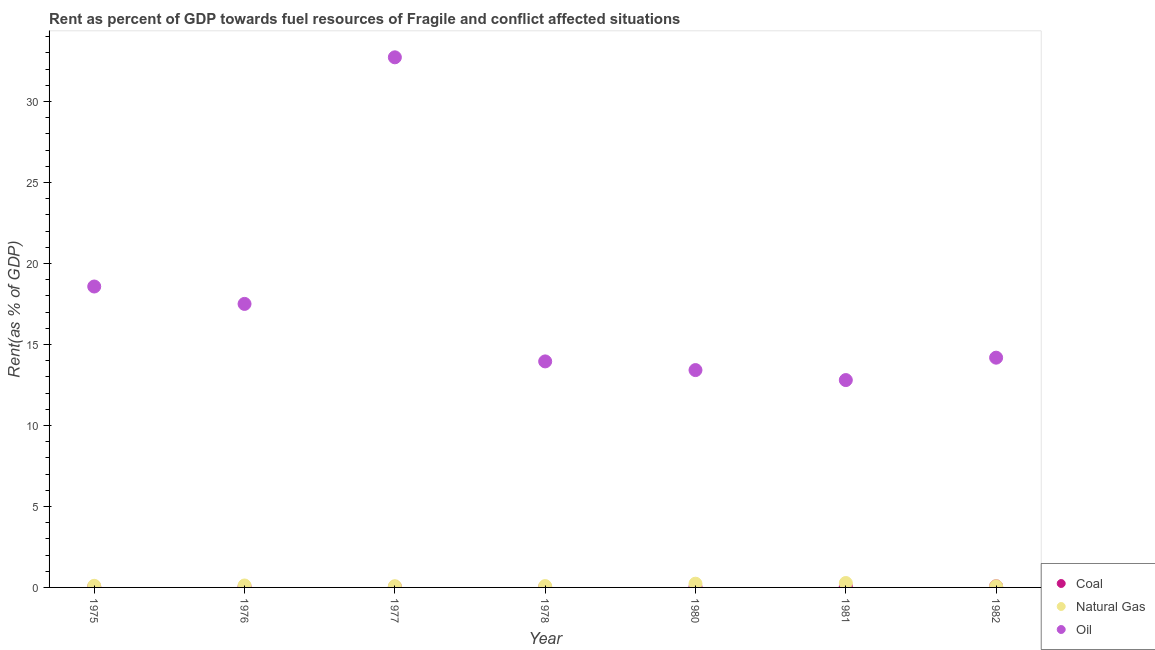Is the number of dotlines equal to the number of legend labels?
Make the answer very short. Yes. What is the rent towards natural gas in 1977?
Offer a terse response. 0.08. Across all years, what is the maximum rent towards natural gas?
Offer a terse response. 0.27. Across all years, what is the minimum rent towards coal?
Provide a short and direct response. 0.02. In which year was the rent towards oil minimum?
Offer a very short reply. 1981. What is the total rent towards natural gas in the graph?
Give a very brief answer. 0.95. What is the difference between the rent towards oil in 1978 and that in 1982?
Ensure brevity in your answer.  -0.23. What is the difference between the rent towards natural gas in 1978 and the rent towards oil in 1977?
Keep it short and to the point. -32.65. What is the average rent towards oil per year?
Provide a short and direct response. 17.6. In the year 1975, what is the difference between the rent towards natural gas and rent towards coal?
Your answer should be compact. 0.06. In how many years, is the rent towards coal greater than 12 %?
Your response must be concise. 0. What is the ratio of the rent towards oil in 1975 to that in 1977?
Offer a terse response. 0.57. What is the difference between the highest and the second highest rent towards oil?
Provide a short and direct response. 14.15. What is the difference between the highest and the lowest rent towards natural gas?
Make the answer very short. 0.2. Is the sum of the rent towards natural gas in 1977 and 1981 greater than the maximum rent towards oil across all years?
Offer a terse response. No. Is it the case that in every year, the sum of the rent towards coal and rent towards natural gas is greater than the rent towards oil?
Your response must be concise. No. Is the rent towards oil strictly greater than the rent towards natural gas over the years?
Ensure brevity in your answer.  Yes. How many years are there in the graph?
Make the answer very short. 7. What is the difference between two consecutive major ticks on the Y-axis?
Make the answer very short. 5. Are the values on the major ticks of Y-axis written in scientific E-notation?
Offer a terse response. No. Does the graph contain grids?
Provide a succinct answer. No. Where does the legend appear in the graph?
Make the answer very short. Bottom right. What is the title of the graph?
Provide a succinct answer. Rent as percent of GDP towards fuel resources of Fragile and conflict affected situations. What is the label or title of the Y-axis?
Provide a short and direct response. Rent(as % of GDP). What is the Rent(as % of GDP) of Coal in 1975?
Your response must be concise. 0.04. What is the Rent(as % of GDP) of Natural Gas in 1975?
Your answer should be compact. 0.1. What is the Rent(as % of GDP) of Oil in 1975?
Offer a very short reply. 18.58. What is the Rent(as % of GDP) of Coal in 1976?
Offer a very short reply. 0.05. What is the Rent(as % of GDP) in Natural Gas in 1976?
Make the answer very short. 0.12. What is the Rent(as % of GDP) of Oil in 1976?
Keep it short and to the point. 17.5. What is the Rent(as % of GDP) of Coal in 1977?
Make the answer very short. 0.04. What is the Rent(as % of GDP) in Natural Gas in 1977?
Make the answer very short. 0.08. What is the Rent(as % of GDP) in Oil in 1977?
Offer a terse response. 32.73. What is the Rent(as % of GDP) in Coal in 1978?
Give a very brief answer. 0.02. What is the Rent(as % of GDP) of Natural Gas in 1978?
Ensure brevity in your answer.  0.08. What is the Rent(as % of GDP) in Oil in 1978?
Make the answer very short. 13.96. What is the Rent(as % of GDP) of Coal in 1980?
Offer a terse response. 0.03. What is the Rent(as % of GDP) in Natural Gas in 1980?
Offer a very short reply. 0.23. What is the Rent(as % of GDP) of Oil in 1980?
Give a very brief answer. 13.42. What is the Rent(as % of GDP) in Coal in 1981?
Ensure brevity in your answer.  0.07. What is the Rent(as % of GDP) of Natural Gas in 1981?
Give a very brief answer. 0.27. What is the Rent(as % of GDP) in Oil in 1981?
Provide a short and direct response. 12.8. What is the Rent(as % of GDP) in Coal in 1982?
Provide a short and direct response. 0.07. What is the Rent(as % of GDP) in Natural Gas in 1982?
Your answer should be compact. 0.07. What is the Rent(as % of GDP) in Oil in 1982?
Give a very brief answer. 14.19. Across all years, what is the maximum Rent(as % of GDP) in Coal?
Your answer should be compact. 0.07. Across all years, what is the maximum Rent(as % of GDP) in Natural Gas?
Provide a short and direct response. 0.27. Across all years, what is the maximum Rent(as % of GDP) of Oil?
Provide a short and direct response. 32.73. Across all years, what is the minimum Rent(as % of GDP) of Coal?
Make the answer very short. 0.02. Across all years, what is the minimum Rent(as % of GDP) in Natural Gas?
Give a very brief answer. 0.07. Across all years, what is the minimum Rent(as % of GDP) of Oil?
Provide a short and direct response. 12.8. What is the total Rent(as % of GDP) in Coal in the graph?
Offer a very short reply. 0.31. What is the total Rent(as % of GDP) of Natural Gas in the graph?
Provide a succinct answer. 0.95. What is the total Rent(as % of GDP) in Oil in the graph?
Keep it short and to the point. 123.17. What is the difference between the Rent(as % of GDP) of Coal in 1975 and that in 1976?
Keep it short and to the point. -0. What is the difference between the Rent(as % of GDP) of Natural Gas in 1975 and that in 1976?
Provide a short and direct response. -0.02. What is the difference between the Rent(as % of GDP) in Oil in 1975 and that in 1976?
Your answer should be compact. 1.07. What is the difference between the Rent(as % of GDP) in Coal in 1975 and that in 1977?
Keep it short and to the point. 0.01. What is the difference between the Rent(as % of GDP) in Natural Gas in 1975 and that in 1977?
Give a very brief answer. 0.02. What is the difference between the Rent(as % of GDP) in Oil in 1975 and that in 1977?
Make the answer very short. -14.15. What is the difference between the Rent(as % of GDP) of Coal in 1975 and that in 1978?
Offer a very short reply. 0.02. What is the difference between the Rent(as % of GDP) in Natural Gas in 1975 and that in 1978?
Provide a short and direct response. 0.02. What is the difference between the Rent(as % of GDP) in Oil in 1975 and that in 1978?
Your answer should be compact. 4.62. What is the difference between the Rent(as % of GDP) in Coal in 1975 and that in 1980?
Ensure brevity in your answer.  0.01. What is the difference between the Rent(as % of GDP) of Natural Gas in 1975 and that in 1980?
Your response must be concise. -0.13. What is the difference between the Rent(as % of GDP) in Oil in 1975 and that in 1980?
Your answer should be compact. 5.16. What is the difference between the Rent(as % of GDP) of Coal in 1975 and that in 1981?
Ensure brevity in your answer.  -0.02. What is the difference between the Rent(as % of GDP) of Natural Gas in 1975 and that in 1981?
Offer a terse response. -0.17. What is the difference between the Rent(as % of GDP) in Oil in 1975 and that in 1981?
Offer a terse response. 5.78. What is the difference between the Rent(as % of GDP) of Coal in 1975 and that in 1982?
Keep it short and to the point. -0.02. What is the difference between the Rent(as % of GDP) in Natural Gas in 1975 and that in 1982?
Keep it short and to the point. 0.03. What is the difference between the Rent(as % of GDP) of Oil in 1975 and that in 1982?
Your answer should be very brief. 4.39. What is the difference between the Rent(as % of GDP) in Coal in 1976 and that in 1977?
Offer a terse response. 0.01. What is the difference between the Rent(as % of GDP) of Natural Gas in 1976 and that in 1977?
Your response must be concise. 0.04. What is the difference between the Rent(as % of GDP) in Oil in 1976 and that in 1977?
Offer a terse response. -15.22. What is the difference between the Rent(as % of GDP) of Coal in 1976 and that in 1978?
Offer a very short reply. 0.02. What is the difference between the Rent(as % of GDP) of Natural Gas in 1976 and that in 1978?
Keep it short and to the point. 0.04. What is the difference between the Rent(as % of GDP) of Oil in 1976 and that in 1978?
Ensure brevity in your answer.  3.55. What is the difference between the Rent(as % of GDP) of Coal in 1976 and that in 1980?
Give a very brief answer. 0.01. What is the difference between the Rent(as % of GDP) of Natural Gas in 1976 and that in 1980?
Your answer should be compact. -0.11. What is the difference between the Rent(as % of GDP) in Oil in 1976 and that in 1980?
Offer a very short reply. 4.09. What is the difference between the Rent(as % of GDP) of Coal in 1976 and that in 1981?
Keep it short and to the point. -0.02. What is the difference between the Rent(as % of GDP) in Natural Gas in 1976 and that in 1981?
Offer a very short reply. -0.15. What is the difference between the Rent(as % of GDP) of Oil in 1976 and that in 1981?
Your answer should be compact. 4.7. What is the difference between the Rent(as % of GDP) in Coal in 1976 and that in 1982?
Your answer should be compact. -0.02. What is the difference between the Rent(as % of GDP) of Natural Gas in 1976 and that in 1982?
Your answer should be compact. 0.05. What is the difference between the Rent(as % of GDP) of Oil in 1976 and that in 1982?
Your response must be concise. 3.32. What is the difference between the Rent(as % of GDP) in Coal in 1977 and that in 1978?
Provide a short and direct response. 0.01. What is the difference between the Rent(as % of GDP) of Natural Gas in 1977 and that in 1978?
Your answer should be very brief. -0.01. What is the difference between the Rent(as % of GDP) in Oil in 1977 and that in 1978?
Offer a very short reply. 18.77. What is the difference between the Rent(as % of GDP) in Coal in 1977 and that in 1980?
Your response must be concise. 0. What is the difference between the Rent(as % of GDP) in Natural Gas in 1977 and that in 1980?
Make the answer very short. -0.15. What is the difference between the Rent(as % of GDP) of Oil in 1977 and that in 1980?
Provide a short and direct response. 19.31. What is the difference between the Rent(as % of GDP) of Coal in 1977 and that in 1981?
Ensure brevity in your answer.  -0.03. What is the difference between the Rent(as % of GDP) in Natural Gas in 1977 and that in 1981?
Your response must be concise. -0.19. What is the difference between the Rent(as % of GDP) in Oil in 1977 and that in 1981?
Keep it short and to the point. 19.93. What is the difference between the Rent(as % of GDP) in Coal in 1977 and that in 1982?
Your response must be concise. -0.03. What is the difference between the Rent(as % of GDP) in Natural Gas in 1977 and that in 1982?
Offer a terse response. 0. What is the difference between the Rent(as % of GDP) of Oil in 1977 and that in 1982?
Your answer should be compact. 18.54. What is the difference between the Rent(as % of GDP) of Coal in 1978 and that in 1980?
Your answer should be compact. -0.01. What is the difference between the Rent(as % of GDP) in Natural Gas in 1978 and that in 1980?
Offer a terse response. -0.15. What is the difference between the Rent(as % of GDP) of Oil in 1978 and that in 1980?
Your answer should be very brief. 0.54. What is the difference between the Rent(as % of GDP) in Coal in 1978 and that in 1981?
Your answer should be compact. -0.04. What is the difference between the Rent(as % of GDP) of Natural Gas in 1978 and that in 1981?
Keep it short and to the point. -0.19. What is the difference between the Rent(as % of GDP) of Oil in 1978 and that in 1981?
Offer a very short reply. 1.15. What is the difference between the Rent(as % of GDP) of Coal in 1978 and that in 1982?
Offer a very short reply. -0.05. What is the difference between the Rent(as % of GDP) of Natural Gas in 1978 and that in 1982?
Ensure brevity in your answer.  0.01. What is the difference between the Rent(as % of GDP) in Oil in 1978 and that in 1982?
Give a very brief answer. -0.23. What is the difference between the Rent(as % of GDP) in Coal in 1980 and that in 1981?
Give a very brief answer. -0.03. What is the difference between the Rent(as % of GDP) in Natural Gas in 1980 and that in 1981?
Offer a terse response. -0.04. What is the difference between the Rent(as % of GDP) of Oil in 1980 and that in 1981?
Provide a short and direct response. 0.62. What is the difference between the Rent(as % of GDP) of Coal in 1980 and that in 1982?
Your answer should be very brief. -0.04. What is the difference between the Rent(as % of GDP) in Natural Gas in 1980 and that in 1982?
Keep it short and to the point. 0.16. What is the difference between the Rent(as % of GDP) of Oil in 1980 and that in 1982?
Your answer should be compact. -0.77. What is the difference between the Rent(as % of GDP) of Coal in 1981 and that in 1982?
Offer a very short reply. -0. What is the difference between the Rent(as % of GDP) in Natural Gas in 1981 and that in 1982?
Your response must be concise. 0.2. What is the difference between the Rent(as % of GDP) of Oil in 1981 and that in 1982?
Make the answer very short. -1.38. What is the difference between the Rent(as % of GDP) in Coal in 1975 and the Rent(as % of GDP) in Natural Gas in 1976?
Your answer should be compact. -0.08. What is the difference between the Rent(as % of GDP) in Coal in 1975 and the Rent(as % of GDP) in Oil in 1976?
Offer a terse response. -17.46. What is the difference between the Rent(as % of GDP) of Natural Gas in 1975 and the Rent(as % of GDP) of Oil in 1976?
Provide a short and direct response. -17.41. What is the difference between the Rent(as % of GDP) of Coal in 1975 and the Rent(as % of GDP) of Natural Gas in 1977?
Make the answer very short. -0.03. What is the difference between the Rent(as % of GDP) in Coal in 1975 and the Rent(as % of GDP) in Oil in 1977?
Offer a very short reply. -32.69. What is the difference between the Rent(as % of GDP) in Natural Gas in 1975 and the Rent(as % of GDP) in Oil in 1977?
Provide a succinct answer. -32.63. What is the difference between the Rent(as % of GDP) of Coal in 1975 and the Rent(as % of GDP) of Natural Gas in 1978?
Keep it short and to the point. -0.04. What is the difference between the Rent(as % of GDP) in Coal in 1975 and the Rent(as % of GDP) in Oil in 1978?
Make the answer very short. -13.91. What is the difference between the Rent(as % of GDP) in Natural Gas in 1975 and the Rent(as % of GDP) in Oil in 1978?
Offer a terse response. -13.86. What is the difference between the Rent(as % of GDP) in Coal in 1975 and the Rent(as % of GDP) in Natural Gas in 1980?
Make the answer very short. -0.19. What is the difference between the Rent(as % of GDP) of Coal in 1975 and the Rent(as % of GDP) of Oil in 1980?
Provide a succinct answer. -13.38. What is the difference between the Rent(as % of GDP) of Natural Gas in 1975 and the Rent(as % of GDP) of Oil in 1980?
Ensure brevity in your answer.  -13.32. What is the difference between the Rent(as % of GDP) of Coal in 1975 and the Rent(as % of GDP) of Natural Gas in 1981?
Ensure brevity in your answer.  -0.23. What is the difference between the Rent(as % of GDP) of Coal in 1975 and the Rent(as % of GDP) of Oil in 1981?
Your response must be concise. -12.76. What is the difference between the Rent(as % of GDP) of Natural Gas in 1975 and the Rent(as % of GDP) of Oil in 1981?
Your response must be concise. -12.7. What is the difference between the Rent(as % of GDP) in Coal in 1975 and the Rent(as % of GDP) in Natural Gas in 1982?
Offer a terse response. -0.03. What is the difference between the Rent(as % of GDP) of Coal in 1975 and the Rent(as % of GDP) of Oil in 1982?
Provide a short and direct response. -14.14. What is the difference between the Rent(as % of GDP) of Natural Gas in 1975 and the Rent(as % of GDP) of Oil in 1982?
Make the answer very short. -14.09. What is the difference between the Rent(as % of GDP) in Coal in 1976 and the Rent(as % of GDP) in Natural Gas in 1977?
Provide a succinct answer. -0.03. What is the difference between the Rent(as % of GDP) of Coal in 1976 and the Rent(as % of GDP) of Oil in 1977?
Your response must be concise. -32.68. What is the difference between the Rent(as % of GDP) in Natural Gas in 1976 and the Rent(as % of GDP) in Oil in 1977?
Provide a succinct answer. -32.61. What is the difference between the Rent(as % of GDP) of Coal in 1976 and the Rent(as % of GDP) of Natural Gas in 1978?
Offer a terse response. -0.04. What is the difference between the Rent(as % of GDP) of Coal in 1976 and the Rent(as % of GDP) of Oil in 1978?
Make the answer very short. -13.91. What is the difference between the Rent(as % of GDP) of Natural Gas in 1976 and the Rent(as % of GDP) of Oil in 1978?
Offer a very short reply. -13.84. What is the difference between the Rent(as % of GDP) of Coal in 1976 and the Rent(as % of GDP) of Natural Gas in 1980?
Offer a terse response. -0.18. What is the difference between the Rent(as % of GDP) in Coal in 1976 and the Rent(as % of GDP) in Oil in 1980?
Offer a terse response. -13.37. What is the difference between the Rent(as % of GDP) in Natural Gas in 1976 and the Rent(as % of GDP) in Oil in 1980?
Your answer should be very brief. -13.3. What is the difference between the Rent(as % of GDP) of Coal in 1976 and the Rent(as % of GDP) of Natural Gas in 1981?
Provide a succinct answer. -0.23. What is the difference between the Rent(as % of GDP) in Coal in 1976 and the Rent(as % of GDP) in Oil in 1981?
Your response must be concise. -12.76. What is the difference between the Rent(as % of GDP) of Natural Gas in 1976 and the Rent(as % of GDP) of Oil in 1981?
Keep it short and to the point. -12.68. What is the difference between the Rent(as % of GDP) in Coal in 1976 and the Rent(as % of GDP) in Natural Gas in 1982?
Your response must be concise. -0.03. What is the difference between the Rent(as % of GDP) in Coal in 1976 and the Rent(as % of GDP) in Oil in 1982?
Provide a short and direct response. -14.14. What is the difference between the Rent(as % of GDP) in Natural Gas in 1976 and the Rent(as % of GDP) in Oil in 1982?
Your answer should be compact. -14.07. What is the difference between the Rent(as % of GDP) in Coal in 1977 and the Rent(as % of GDP) in Natural Gas in 1978?
Make the answer very short. -0.05. What is the difference between the Rent(as % of GDP) of Coal in 1977 and the Rent(as % of GDP) of Oil in 1978?
Offer a very short reply. -13.92. What is the difference between the Rent(as % of GDP) in Natural Gas in 1977 and the Rent(as % of GDP) in Oil in 1978?
Your answer should be compact. -13.88. What is the difference between the Rent(as % of GDP) of Coal in 1977 and the Rent(as % of GDP) of Natural Gas in 1980?
Make the answer very short. -0.19. What is the difference between the Rent(as % of GDP) of Coal in 1977 and the Rent(as % of GDP) of Oil in 1980?
Your answer should be very brief. -13.38. What is the difference between the Rent(as % of GDP) in Natural Gas in 1977 and the Rent(as % of GDP) in Oil in 1980?
Give a very brief answer. -13.34. What is the difference between the Rent(as % of GDP) in Coal in 1977 and the Rent(as % of GDP) in Natural Gas in 1981?
Your response must be concise. -0.24. What is the difference between the Rent(as % of GDP) of Coal in 1977 and the Rent(as % of GDP) of Oil in 1981?
Provide a short and direct response. -12.77. What is the difference between the Rent(as % of GDP) in Natural Gas in 1977 and the Rent(as % of GDP) in Oil in 1981?
Your answer should be very brief. -12.73. What is the difference between the Rent(as % of GDP) in Coal in 1977 and the Rent(as % of GDP) in Natural Gas in 1982?
Your answer should be very brief. -0.04. What is the difference between the Rent(as % of GDP) in Coal in 1977 and the Rent(as % of GDP) in Oil in 1982?
Your response must be concise. -14.15. What is the difference between the Rent(as % of GDP) of Natural Gas in 1977 and the Rent(as % of GDP) of Oil in 1982?
Offer a terse response. -14.11. What is the difference between the Rent(as % of GDP) in Coal in 1978 and the Rent(as % of GDP) in Natural Gas in 1980?
Provide a succinct answer. -0.21. What is the difference between the Rent(as % of GDP) of Coal in 1978 and the Rent(as % of GDP) of Oil in 1980?
Your answer should be very brief. -13.4. What is the difference between the Rent(as % of GDP) in Natural Gas in 1978 and the Rent(as % of GDP) in Oil in 1980?
Your answer should be very brief. -13.34. What is the difference between the Rent(as % of GDP) in Coal in 1978 and the Rent(as % of GDP) in Natural Gas in 1981?
Keep it short and to the point. -0.25. What is the difference between the Rent(as % of GDP) in Coal in 1978 and the Rent(as % of GDP) in Oil in 1981?
Make the answer very short. -12.78. What is the difference between the Rent(as % of GDP) in Natural Gas in 1978 and the Rent(as % of GDP) in Oil in 1981?
Keep it short and to the point. -12.72. What is the difference between the Rent(as % of GDP) of Coal in 1978 and the Rent(as % of GDP) of Natural Gas in 1982?
Offer a terse response. -0.05. What is the difference between the Rent(as % of GDP) in Coal in 1978 and the Rent(as % of GDP) in Oil in 1982?
Provide a short and direct response. -14.16. What is the difference between the Rent(as % of GDP) of Natural Gas in 1978 and the Rent(as % of GDP) of Oil in 1982?
Make the answer very short. -14.1. What is the difference between the Rent(as % of GDP) in Coal in 1980 and the Rent(as % of GDP) in Natural Gas in 1981?
Provide a short and direct response. -0.24. What is the difference between the Rent(as % of GDP) of Coal in 1980 and the Rent(as % of GDP) of Oil in 1981?
Your answer should be compact. -12.77. What is the difference between the Rent(as % of GDP) in Natural Gas in 1980 and the Rent(as % of GDP) in Oil in 1981?
Ensure brevity in your answer.  -12.57. What is the difference between the Rent(as % of GDP) in Coal in 1980 and the Rent(as % of GDP) in Natural Gas in 1982?
Ensure brevity in your answer.  -0.04. What is the difference between the Rent(as % of GDP) in Coal in 1980 and the Rent(as % of GDP) in Oil in 1982?
Your response must be concise. -14.15. What is the difference between the Rent(as % of GDP) in Natural Gas in 1980 and the Rent(as % of GDP) in Oil in 1982?
Ensure brevity in your answer.  -13.96. What is the difference between the Rent(as % of GDP) of Coal in 1981 and the Rent(as % of GDP) of Natural Gas in 1982?
Offer a very short reply. -0.01. What is the difference between the Rent(as % of GDP) in Coal in 1981 and the Rent(as % of GDP) in Oil in 1982?
Offer a very short reply. -14.12. What is the difference between the Rent(as % of GDP) of Natural Gas in 1981 and the Rent(as % of GDP) of Oil in 1982?
Offer a terse response. -13.91. What is the average Rent(as % of GDP) of Coal per year?
Your answer should be very brief. 0.04. What is the average Rent(as % of GDP) of Natural Gas per year?
Offer a terse response. 0.14. What is the average Rent(as % of GDP) of Oil per year?
Provide a short and direct response. 17.6. In the year 1975, what is the difference between the Rent(as % of GDP) in Coal and Rent(as % of GDP) in Natural Gas?
Your answer should be very brief. -0.06. In the year 1975, what is the difference between the Rent(as % of GDP) in Coal and Rent(as % of GDP) in Oil?
Offer a terse response. -18.53. In the year 1975, what is the difference between the Rent(as % of GDP) in Natural Gas and Rent(as % of GDP) in Oil?
Your answer should be compact. -18.48. In the year 1976, what is the difference between the Rent(as % of GDP) of Coal and Rent(as % of GDP) of Natural Gas?
Make the answer very short. -0.07. In the year 1976, what is the difference between the Rent(as % of GDP) in Coal and Rent(as % of GDP) in Oil?
Offer a terse response. -17.46. In the year 1976, what is the difference between the Rent(as % of GDP) of Natural Gas and Rent(as % of GDP) of Oil?
Keep it short and to the point. -17.38. In the year 1977, what is the difference between the Rent(as % of GDP) in Coal and Rent(as % of GDP) in Natural Gas?
Your answer should be compact. -0.04. In the year 1977, what is the difference between the Rent(as % of GDP) in Coal and Rent(as % of GDP) in Oil?
Provide a short and direct response. -32.69. In the year 1977, what is the difference between the Rent(as % of GDP) in Natural Gas and Rent(as % of GDP) in Oil?
Offer a very short reply. -32.65. In the year 1978, what is the difference between the Rent(as % of GDP) in Coal and Rent(as % of GDP) in Natural Gas?
Your response must be concise. -0.06. In the year 1978, what is the difference between the Rent(as % of GDP) of Coal and Rent(as % of GDP) of Oil?
Offer a terse response. -13.93. In the year 1978, what is the difference between the Rent(as % of GDP) in Natural Gas and Rent(as % of GDP) in Oil?
Offer a terse response. -13.87. In the year 1980, what is the difference between the Rent(as % of GDP) in Coal and Rent(as % of GDP) in Natural Gas?
Your answer should be very brief. -0.2. In the year 1980, what is the difference between the Rent(as % of GDP) in Coal and Rent(as % of GDP) in Oil?
Your answer should be compact. -13.39. In the year 1980, what is the difference between the Rent(as % of GDP) in Natural Gas and Rent(as % of GDP) in Oil?
Your answer should be compact. -13.19. In the year 1981, what is the difference between the Rent(as % of GDP) of Coal and Rent(as % of GDP) of Natural Gas?
Provide a succinct answer. -0.21. In the year 1981, what is the difference between the Rent(as % of GDP) in Coal and Rent(as % of GDP) in Oil?
Your response must be concise. -12.74. In the year 1981, what is the difference between the Rent(as % of GDP) in Natural Gas and Rent(as % of GDP) in Oil?
Offer a very short reply. -12.53. In the year 1982, what is the difference between the Rent(as % of GDP) in Coal and Rent(as % of GDP) in Natural Gas?
Offer a very short reply. -0. In the year 1982, what is the difference between the Rent(as % of GDP) of Coal and Rent(as % of GDP) of Oil?
Make the answer very short. -14.12. In the year 1982, what is the difference between the Rent(as % of GDP) in Natural Gas and Rent(as % of GDP) in Oil?
Your response must be concise. -14.11. What is the ratio of the Rent(as % of GDP) in Coal in 1975 to that in 1976?
Offer a very short reply. 0.95. What is the ratio of the Rent(as % of GDP) in Natural Gas in 1975 to that in 1976?
Offer a terse response. 0.83. What is the ratio of the Rent(as % of GDP) of Oil in 1975 to that in 1976?
Offer a terse response. 1.06. What is the ratio of the Rent(as % of GDP) in Coal in 1975 to that in 1977?
Provide a short and direct response. 1.22. What is the ratio of the Rent(as % of GDP) of Natural Gas in 1975 to that in 1977?
Your response must be concise. 1.3. What is the ratio of the Rent(as % of GDP) of Oil in 1975 to that in 1977?
Offer a terse response. 0.57. What is the ratio of the Rent(as % of GDP) of Coal in 1975 to that in 1978?
Keep it short and to the point. 2.04. What is the ratio of the Rent(as % of GDP) of Natural Gas in 1975 to that in 1978?
Your answer should be compact. 1.19. What is the ratio of the Rent(as % of GDP) of Oil in 1975 to that in 1978?
Provide a short and direct response. 1.33. What is the ratio of the Rent(as % of GDP) in Coal in 1975 to that in 1980?
Provide a succinct answer. 1.36. What is the ratio of the Rent(as % of GDP) in Natural Gas in 1975 to that in 1980?
Ensure brevity in your answer.  0.43. What is the ratio of the Rent(as % of GDP) in Oil in 1975 to that in 1980?
Your answer should be compact. 1.38. What is the ratio of the Rent(as % of GDP) in Coal in 1975 to that in 1981?
Give a very brief answer. 0.66. What is the ratio of the Rent(as % of GDP) of Natural Gas in 1975 to that in 1981?
Offer a terse response. 0.37. What is the ratio of the Rent(as % of GDP) in Oil in 1975 to that in 1981?
Ensure brevity in your answer.  1.45. What is the ratio of the Rent(as % of GDP) of Coal in 1975 to that in 1982?
Give a very brief answer. 0.64. What is the ratio of the Rent(as % of GDP) of Natural Gas in 1975 to that in 1982?
Your response must be concise. 1.38. What is the ratio of the Rent(as % of GDP) in Oil in 1975 to that in 1982?
Provide a short and direct response. 1.31. What is the ratio of the Rent(as % of GDP) of Coal in 1976 to that in 1977?
Your answer should be compact. 1.29. What is the ratio of the Rent(as % of GDP) of Natural Gas in 1976 to that in 1977?
Provide a short and direct response. 1.56. What is the ratio of the Rent(as % of GDP) of Oil in 1976 to that in 1977?
Give a very brief answer. 0.53. What is the ratio of the Rent(as % of GDP) of Coal in 1976 to that in 1978?
Your answer should be very brief. 2.15. What is the ratio of the Rent(as % of GDP) in Natural Gas in 1976 to that in 1978?
Your answer should be very brief. 1.43. What is the ratio of the Rent(as % of GDP) of Oil in 1976 to that in 1978?
Offer a very short reply. 1.25. What is the ratio of the Rent(as % of GDP) of Coal in 1976 to that in 1980?
Offer a very short reply. 1.44. What is the ratio of the Rent(as % of GDP) of Natural Gas in 1976 to that in 1980?
Offer a terse response. 0.52. What is the ratio of the Rent(as % of GDP) in Oil in 1976 to that in 1980?
Your answer should be very brief. 1.3. What is the ratio of the Rent(as % of GDP) of Coal in 1976 to that in 1981?
Provide a short and direct response. 0.7. What is the ratio of the Rent(as % of GDP) of Natural Gas in 1976 to that in 1981?
Offer a terse response. 0.44. What is the ratio of the Rent(as % of GDP) in Oil in 1976 to that in 1981?
Your answer should be compact. 1.37. What is the ratio of the Rent(as % of GDP) in Coal in 1976 to that in 1982?
Keep it short and to the point. 0.67. What is the ratio of the Rent(as % of GDP) in Natural Gas in 1976 to that in 1982?
Your response must be concise. 1.66. What is the ratio of the Rent(as % of GDP) in Oil in 1976 to that in 1982?
Ensure brevity in your answer.  1.23. What is the ratio of the Rent(as % of GDP) of Coal in 1977 to that in 1978?
Your answer should be very brief. 1.67. What is the ratio of the Rent(as % of GDP) in Natural Gas in 1977 to that in 1978?
Provide a succinct answer. 0.91. What is the ratio of the Rent(as % of GDP) of Oil in 1977 to that in 1978?
Make the answer very short. 2.35. What is the ratio of the Rent(as % of GDP) of Coal in 1977 to that in 1980?
Offer a very short reply. 1.12. What is the ratio of the Rent(as % of GDP) of Natural Gas in 1977 to that in 1980?
Provide a short and direct response. 0.33. What is the ratio of the Rent(as % of GDP) in Oil in 1977 to that in 1980?
Your answer should be very brief. 2.44. What is the ratio of the Rent(as % of GDP) in Coal in 1977 to that in 1981?
Offer a terse response. 0.54. What is the ratio of the Rent(as % of GDP) in Natural Gas in 1977 to that in 1981?
Your response must be concise. 0.28. What is the ratio of the Rent(as % of GDP) of Oil in 1977 to that in 1981?
Offer a terse response. 2.56. What is the ratio of the Rent(as % of GDP) in Coal in 1977 to that in 1982?
Ensure brevity in your answer.  0.52. What is the ratio of the Rent(as % of GDP) in Natural Gas in 1977 to that in 1982?
Ensure brevity in your answer.  1.06. What is the ratio of the Rent(as % of GDP) in Oil in 1977 to that in 1982?
Give a very brief answer. 2.31. What is the ratio of the Rent(as % of GDP) of Coal in 1978 to that in 1980?
Offer a very short reply. 0.67. What is the ratio of the Rent(as % of GDP) in Natural Gas in 1978 to that in 1980?
Provide a short and direct response. 0.37. What is the ratio of the Rent(as % of GDP) of Oil in 1978 to that in 1980?
Provide a short and direct response. 1.04. What is the ratio of the Rent(as % of GDP) in Coal in 1978 to that in 1981?
Your answer should be compact. 0.33. What is the ratio of the Rent(as % of GDP) in Natural Gas in 1978 to that in 1981?
Offer a terse response. 0.31. What is the ratio of the Rent(as % of GDP) of Oil in 1978 to that in 1981?
Offer a very short reply. 1.09. What is the ratio of the Rent(as % of GDP) of Coal in 1978 to that in 1982?
Give a very brief answer. 0.31. What is the ratio of the Rent(as % of GDP) in Natural Gas in 1978 to that in 1982?
Provide a succinct answer. 1.17. What is the ratio of the Rent(as % of GDP) in Oil in 1978 to that in 1982?
Offer a very short reply. 0.98. What is the ratio of the Rent(as % of GDP) in Coal in 1980 to that in 1981?
Make the answer very short. 0.49. What is the ratio of the Rent(as % of GDP) of Natural Gas in 1980 to that in 1981?
Offer a terse response. 0.85. What is the ratio of the Rent(as % of GDP) in Oil in 1980 to that in 1981?
Your answer should be compact. 1.05. What is the ratio of the Rent(as % of GDP) in Coal in 1980 to that in 1982?
Make the answer very short. 0.47. What is the ratio of the Rent(as % of GDP) in Natural Gas in 1980 to that in 1982?
Offer a very short reply. 3.19. What is the ratio of the Rent(as % of GDP) of Oil in 1980 to that in 1982?
Your response must be concise. 0.95. What is the ratio of the Rent(as % of GDP) in Coal in 1981 to that in 1982?
Keep it short and to the point. 0.96. What is the ratio of the Rent(as % of GDP) in Natural Gas in 1981 to that in 1982?
Give a very brief answer. 3.76. What is the ratio of the Rent(as % of GDP) of Oil in 1981 to that in 1982?
Your answer should be very brief. 0.9. What is the difference between the highest and the second highest Rent(as % of GDP) of Coal?
Offer a terse response. 0. What is the difference between the highest and the second highest Rent(as % of GDP) in Natural Gas?
Give a very brief answer. 0.04. What is the difference between the highest and the second highest Rent(as % of GDP) of Oil?
Keep it short and to the point. 14.15. What is the difference between the highest and the lowest Rent(as % of GDP) of Coal?
Keep it short and to the point. 0.05. What is the difference between the highest and the lowest Rent(as % of GDP) of Natural Gas?
Your answer should be very brief. 0.2. What is the difference between the highest and the lowest Rent(as % of GDP) in Oil?
Your response must be concise. 19.93. 